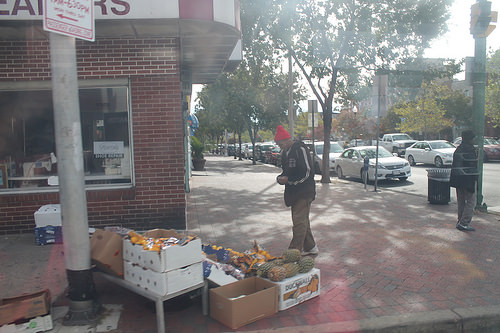<image>
Can you confirm if the pole is on the box? No. The pole is not positioned on the box. They may be near each other, but the pole is not supported by or resting on top of the box. Where is the person in relation to the person? Is it in front of the person? No. The person is not in front of the person. The spatial positioning shows a different relationship between these objects. 